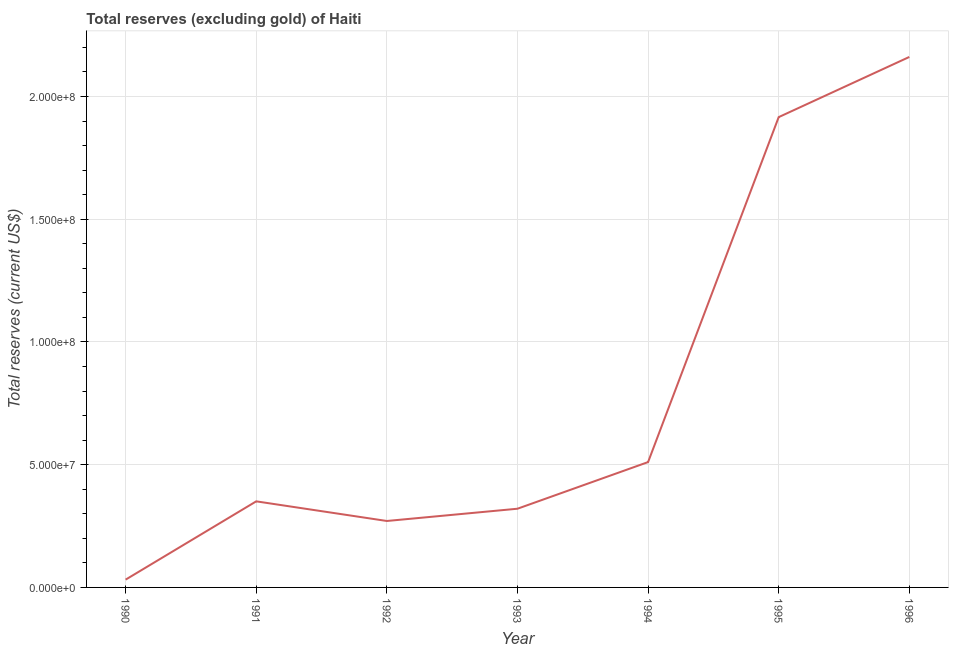What is the total reserves (excluding gold) in 1991?
Provide a short and direct response. 3.51e+07. Across all years, what is the maximum total reserves (excluding gold)?
Offer a very short reply. 2.16e+08. Across all years, what is the minimum total reserves (excluding gold)?
Your answer should be very brief. 3.17e+06. In which year was the total reserves (excluding gold) minimum?
Keep it short and to the point. 1990. What is the sum of the total reserves (excluding gold)?
Your response must be concise. 5.56e+08. What is the difference between the total reserves (excluding gold) in 1994 and 1995?
Offer a very short reply. -1.41e+08. What is the average total reserves (excluding gold) per year?
Provide a succinct answer. 7.95e+07. What is the median total reserves (excluding gold)?
Make the answer very short. 3.51e+07. Do a majority of the years between 1994 and 1993 (inclusive) have total reserves (excluding gold) greater than 90000000 US$?
Provide a succinct answer. No. What is the ratio of the total reserves (excluding gold) in 1991 to that in 1994?
Make the answer very short. 0.69. Is the total reserves (excluding gold) in 1992 less than that in 1996?
Make the answer very short. Yes. Is the difference between the total reserves (excluding gold) in 1991 and 1993 greater than the difference between any two years?
Your answer should be compact. No. What is the difference between the highest and the second highest total reserves (excluding gold)?
Keep it short and to the point. 2.45e+07. What is the difference between the highest and the lowest total reserves (excluding gold)?
Your response must be concise. 2.13e+08. Does the total reserves (excluding gold) monotonically increase over the years?
Your answer should be compact. No. How many years are there in the graph?
Your answer should be very brief. 7. Are the values on the major ticks of Y-axis written in scientific E-notation?
Provide a succinct answer. Yes. What is the title of the graph?
Your response must be concise. Total reserves (excluding gold) of Haiti. What is the label or title of the X-axis?
Provide a short and direct response. Year. What is the label or title of the Y-axis?
Your answer should be compact. Total reserves (current US$). What is the Total reserves (current US$) of 1990?
Provide a short and direct response. 3.17e+06. What is the Total reserves (current US$) in 1991?
Give a very brief answer. 3.51e+07. What is the Total reserves (current US$) in 1992?
Provide a succinct answer. 2.71e+07. What is the Total reserves (current US$) of 1993?
Keep it short and to the point. 3.21e+07. What is the Total reserves (current US$) in 1994?
Give a very brief answer. 5.11e+07. What is the Total reserves (current US$) of 1995?
Provide a succinct answer. 1.92e+08. What is the Total reserves (current US$) of 1996?
Ensure brevity in your answer.  2.16e+08. What is the difference between the Total reserves (current US$) in 1990 and 1991?
Offer a very short reply. -3.19e+07. What is the difference between the Total reserves (current US$) in 1990 and 1992?
Provide a short and direct response. -2.39e+07. What is the difference between the Total reserves (current US$) in 1990 and 1993?
Ensure brevity in your answer.  -2.89e+07. What is the difference between the Total reserves (current US$) in 1990 and 1994?
Your response must be concise. -4.79e+07. What is the difference between the Total reserves (current US$) in 1990 and 1995?
Provide a short and direct response. -1.88e+08. What is the difference between the Total reserves (current US$) in 1990 and 1996?
Your answer should be compact. -2.13e+08. What is the difference between the Total reserves (current US$) in 1991 and 1992?
Give a very brief answer. 8.00e+06. What is the difference between the Total reserves (current US$) in 1991 and 1993?
Your answer should be compact. 3.01e+06. What is the difference between the Total reserves (current US$) in 1991 and 1994?
Offer a very short reply. -1.60e+07. What is the difference between the Total reserves (current US$) in 1991 and 1995?
Make the answer very short. -1.57e+08. What is the difference between the Total reserves (current US$) in 1991 and 1996?
Make the answer very short. -1.81e+08. What is the difference between the Total reserves (current US$) in 1992 and 1993?
Provide a short and direct response. -4.99e+06. What is the difference between the Total reserves (current US$) in 1992 and 1994?
Your answer should be very brief. -2.40e+07. What is the difference between the Total reserves (current US$) in 1992 and 1995?
Ensure brevity in your answer.  -1.65e+08. What is the difference between the Total reserves (current US$) in 1992 and 1996?
Provide a short and direct response. -1.89e+08. What is the difference between the Total reserves (current US$) in 1993 and 1994?
Your answer should be very brief. -1.90e+07. What is the difference between the Total reserves (current US$) in 1993 and 1995?
Offer a very short reply. -1.60e+08. What is the difference between the Total reserves (current US$) in 1993 and 1996?
Your response must be concise. -1.84e+08. What is the difference between the Total reserves (current US$) in 1994 and 1995?
Your answer should be compact. -1.41e+08. What is the difference between the Total reserves (current US$) in 1994 and 1996?
Provide a short and direct response. -1.65e+08. What is the difference between the Total reserves (current US$) in 1995 and 1996?
Keep it short and to the point. -2.45e+07. What is the ratio of the Total reserves (current US$) in 1990 to that in 1991?
Offer a terse response. 0.09. What is the ratio of the Total reserves (current US$) in 1990 to that in 1992?
Your answer should be very brief. 0.12. What is the ratio of the Total reserves (current US$) in 1990 to that in 1993?
Provide a short and direct response. 0.1. What is the ratio of the Total reserves (current US$) in 1990 to that in 1994?
Keep it short and to the point. 0.06. What is the ratio of the Total reserves (current US$) in 1990 to that in 1995?
Provide a succinct answer. 0.02. What is the ratio of the Total reserves (current US$) in 1990 to that in 1996?
Offer a terse response. 0.01. What is the ratio of the Total reserves (current US$) in 1991 to that in 1992?
Offer a terse response. 1.3. What is the ratio of the Total reserves (current US$) in 1991 to that in 1993?
Provide a short and direct response. 1.09. What is the ratio of the Total reserves (current US$) in 1991 to that in 1994?
Offer a very short reply. 0.69. What is the ratio of the Total reserves (current US$) in 1991 to that in 1995?
Offer a very short reply. 0.18. What is the ratio of the Total reserves (current US$) in 1991 to that in 1996?
Give a very brief answer. 0.16. What is the ratio of the Total reserves (current US$) in 1992 to that in 1993?
Provide a short and direct response. 0.84. What is the ratio of the Total reserves (current US$) in 1992 to that in 1994?
Offer a very short reply. 0.53. What is the ratio of the Total reserves (current US$) in 1992 to that in 1995?
Give a very brief answer. 0.14. What is the ratio of the Total reserves (current US$) in 1993 to that in 1994?
Your answer should be very brief. 0.63. What is the ratio of the Total reserves (current US$) in 1993 to that in 1995?
Keep it short and to the point. 0.17. What is the ratio of the Total reserves (current US$) in 1993 to that in 1996?
Provide a succinct answer. 0.15. What is the ratio of the Total reserves (current US$) in 1994 to that in 1995?
Make the answer very short. 0.27. What is the ratio of the Total reserves (current US$) in 1994 to that in 1996?
Offer a terse response. 0.24. What is the ratio of the Total reserves (current US$) in 1995 to that in 1996?
Offer a very short reply. 0.89. 